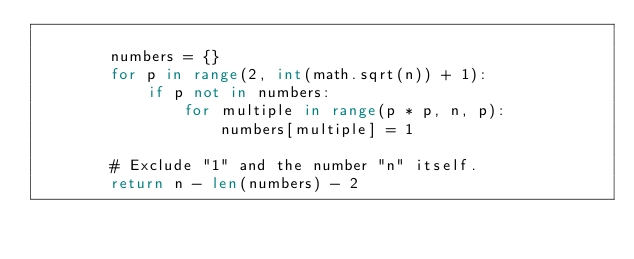<code> <loc_0><loc_0><loc_500><loc_500><_Python_>
        numbers = {}
        for p in range(2, int(math.sqrt(n)) + 1):
            if p not in numbers:
                for multiple in range(p * p, n, p):
                    numbers[multiple] = 1

        # Exclude "1" and the number "n" itself.
        return n - len(numbers) - 2
</code> 